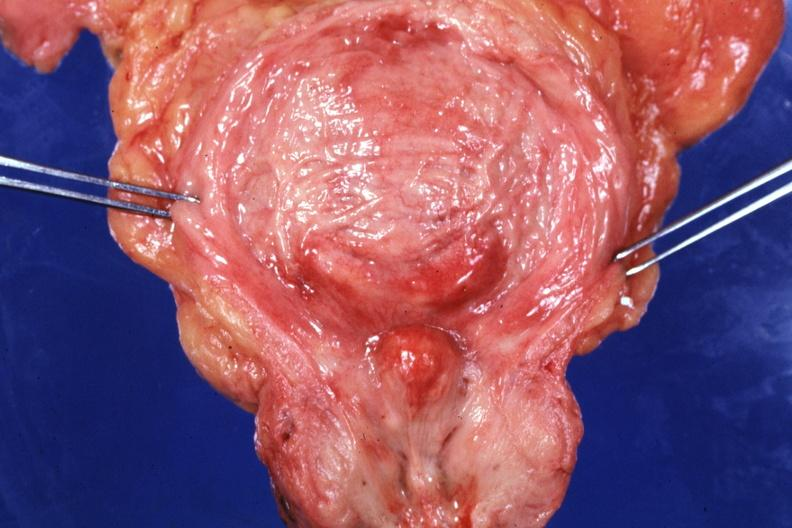what does this image show?
Answer the question using a single word or phrase. Opened bladder with median lobe protruding into trigone area also had increase bladder trabeculations very good slide 